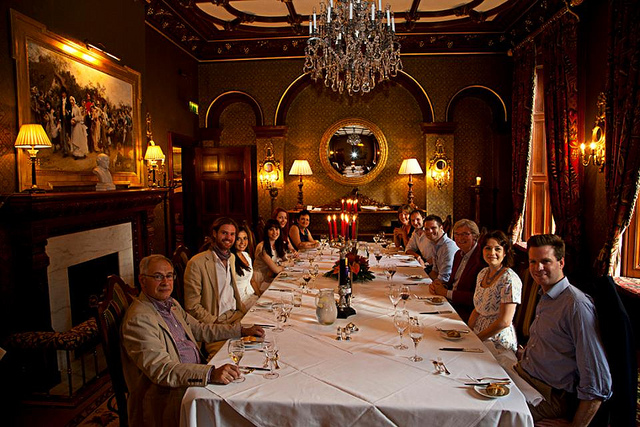<image>What food is on the plate? There is no food on the plate. However, it can be salad, rolls or bread. What food is on the plate? I am not sure what food is on the plate. It can be seen salad, rolls, bread or dinner. 